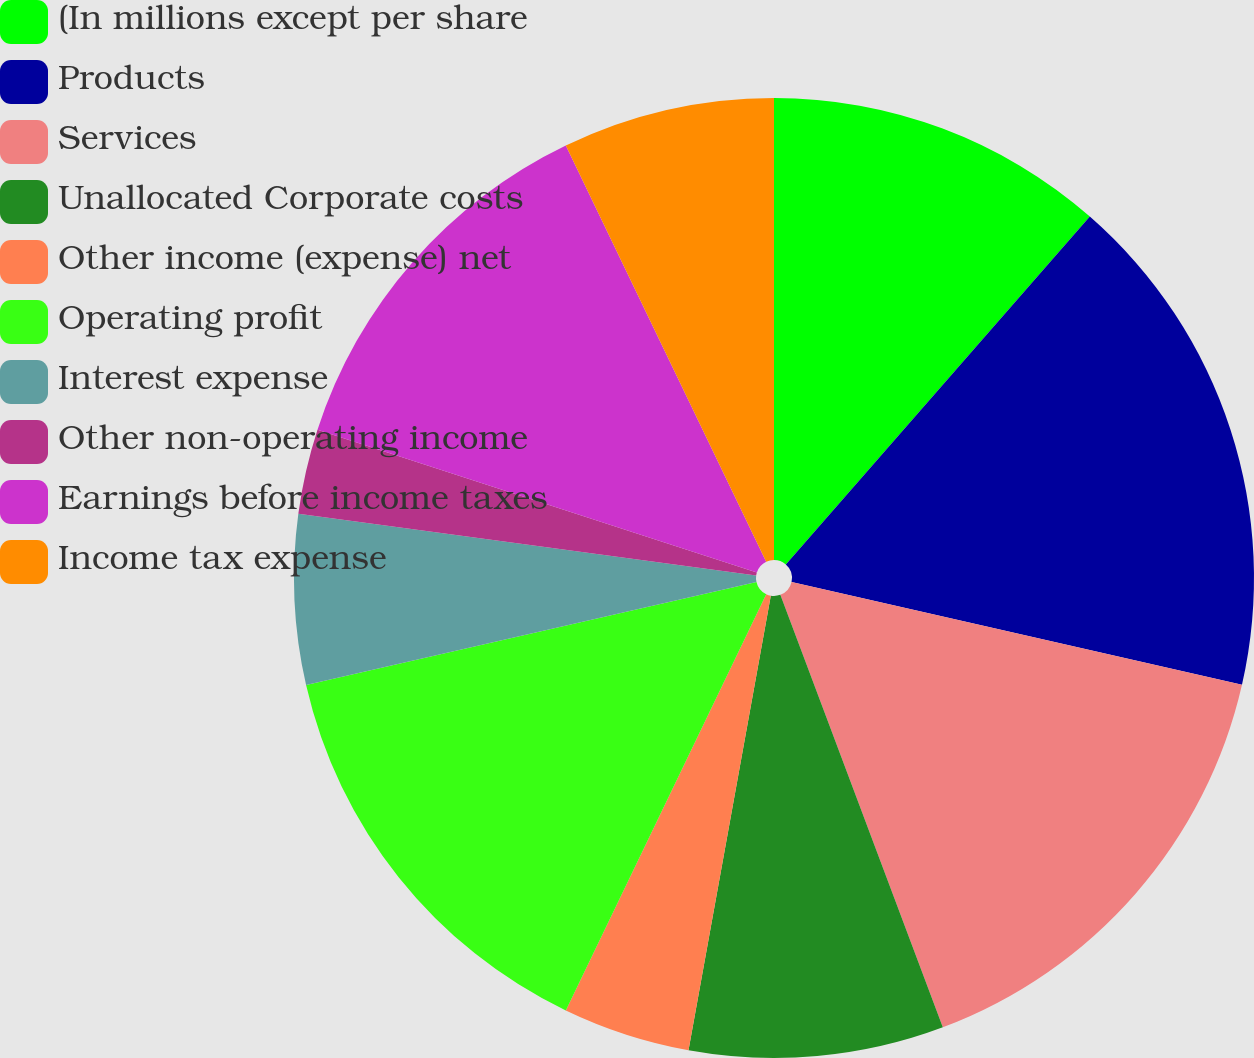<chart> <loc_0><loc_0><loc_500><loc_500><pie_chart><fcel>(In millions except per share<fcel>Products<fcel>Services<fcel>Unallocated Corporate costs<fcel>Other income (expense) net<fcel>Operating profit<fcel>Interest expense<fcel>Other non-operating income<fcel>Earnings before income taxes<fcel>Income tax expense<nl><fcel>11.43%<fcel>17.14%<fcel>15.71%<fcel>8.57%<fcel>4.29%<fcel>14.28%<fcel>5.72%<fcel>2.86%<fcel>12.86%<fcel>7.14%<nl></chart> 